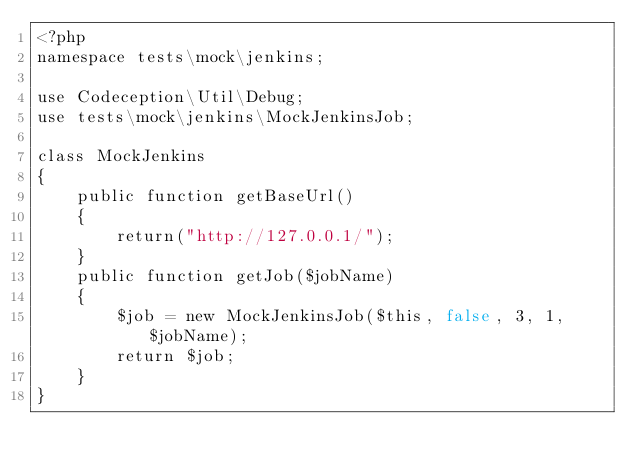<code> <loc_0><loc_0><loc_500><loc_500><_PHP_><?php
namespace tests\mock\jenkins;

use Codeception\Util\Debug;
use tests\mock\jenkins\MockJenkinsJob;

class MockJenkins
{
    public function getBaseUrl()
    {
        return("http://127.0.0.1/");
    }
    public function getJob($jobName)
    {
        $job = new MockJenkinsJob($this, false, 3, 1, $jobName);
        return $job;
    }
}

</code> 